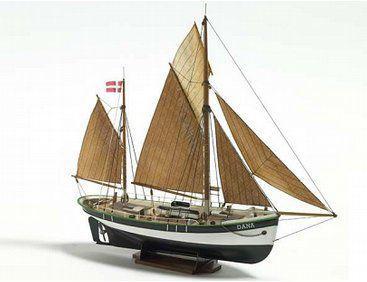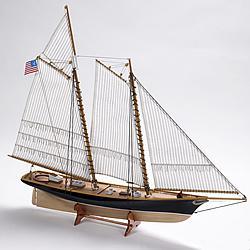The first image is the image on the left, the second image is the image on the right. Assess this claim about the two images: "The boat in one of the images has exactly 6 sails". Correct or not? Answer yes or no. No. 